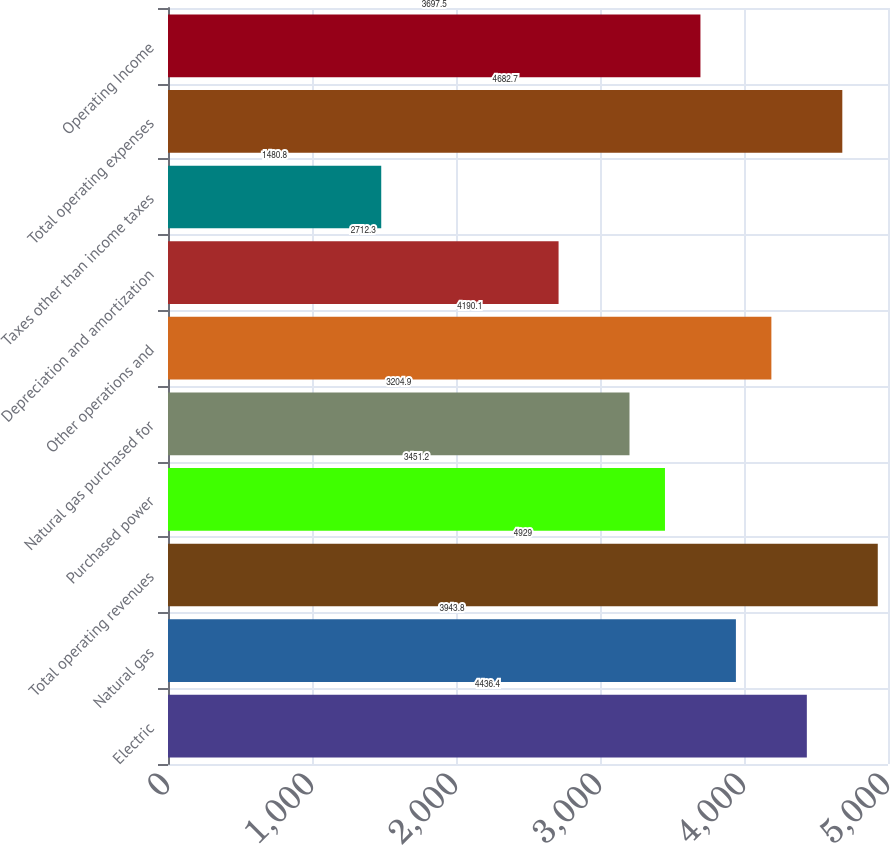Convert chart to OTSL. <chart><loc_0><loc_0><loc_500><loc_500><bar_chart><fcel>Electric<fcel>Natural gas<fcel>Total operating revenues<fcel>Purchased power<fcel>Natural gas purchased for<fcel>Other operations and<fcel>Depreciation and amortization<fcel>Taxes other than income taxes<fcel>Total operating expenses<fcel>Operating Income<nl><fcel>4436.4<fcel>3943.8<fcel>4929<fcel>3451.2<fcel>3204.9<fcel>4190.1<fcel>2712.3<fcel>1480.8<fcel>4682.7<fcel>3697.5<nl></chart> 